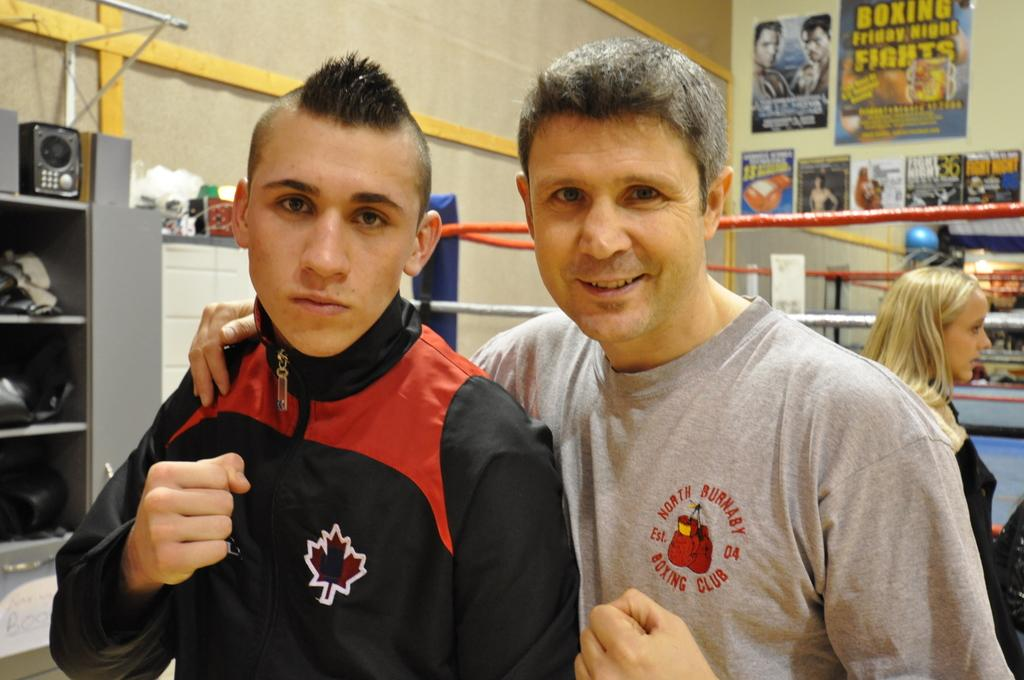Provide a one-sentence caption for the provided image. Two guys posing, one wearing a Boxing Club shirt. 